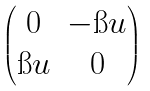<formula> <loc_0><loc_0><loc_500><loc_500>\begin{pmatrix} 0 & - \i u \\ \i u & 0 \end{pmatrix}</formula> 